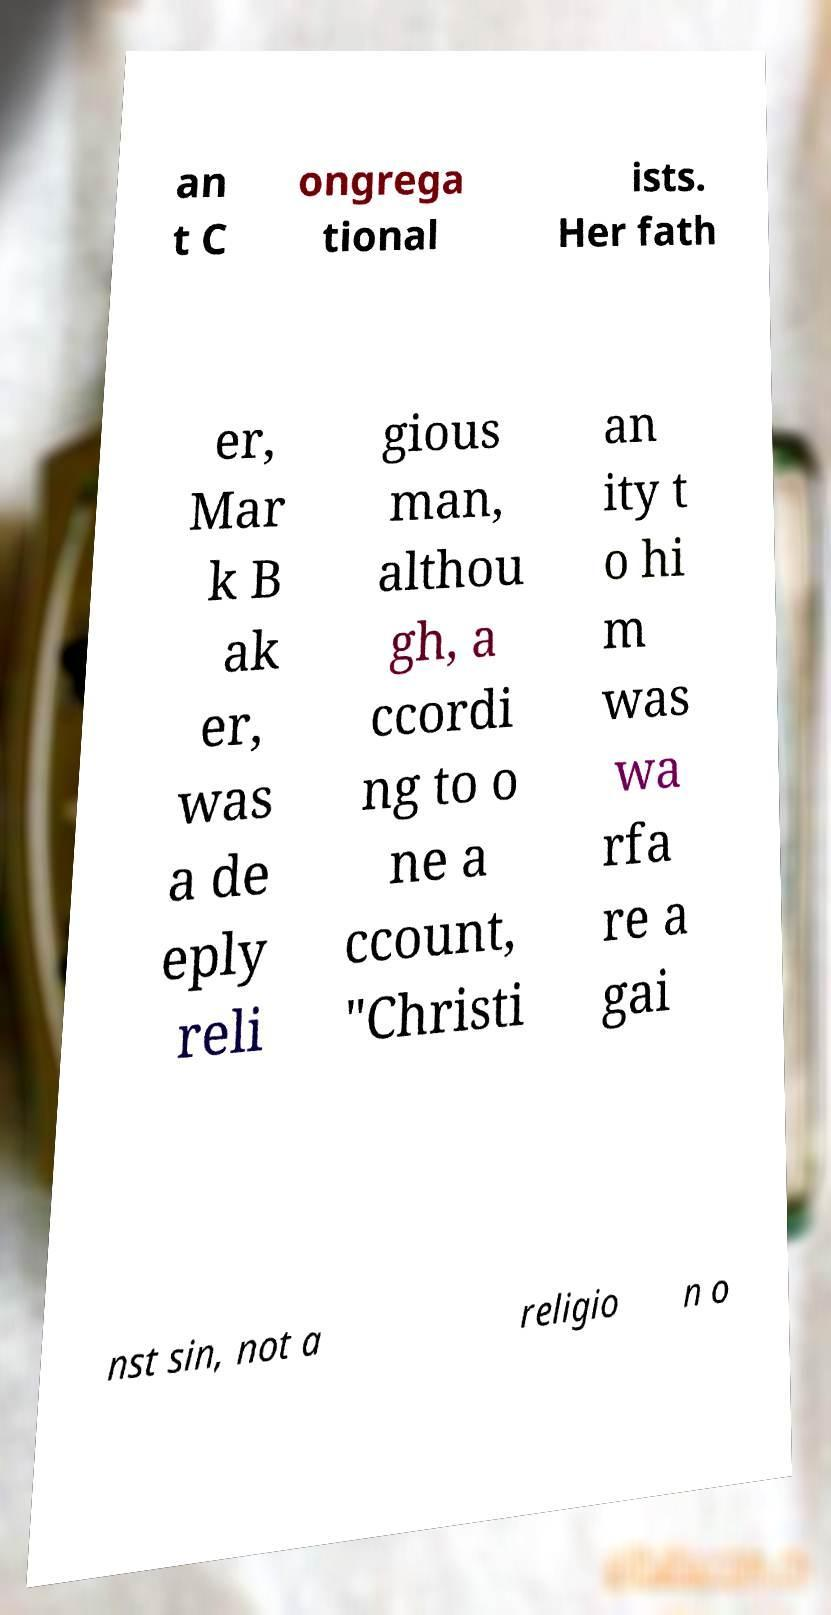Can you read and provide the text displayed in the image?This photo seems to have some interesting text. Can you extract and type it out for me? an t C ongrega tional ists. Her fath er, Mar k B ak er, was a de eply reli gious man, althou gh, a ccordi ng to o ne a ccount, "Christi an ity t o hi m was wa rfa re a gai nst sin, not a religio n o 